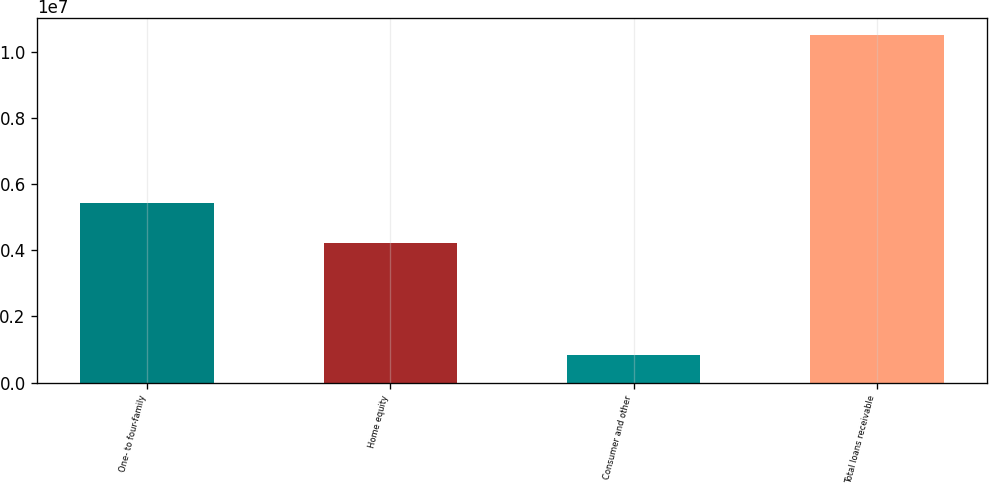Convert chart to OTSL. <chart><loc_0><loc_0><loc_500><loc_500><bar_chart><fcel>One- to four-family<fcel>Home equity<fcel>Consumer and other<fcel>Total loans receivable<nl><fcel>5.44217e+06<fcel>4.22346e+06<fcel>844942<fcel>1.05106e+07<nl></chart> 